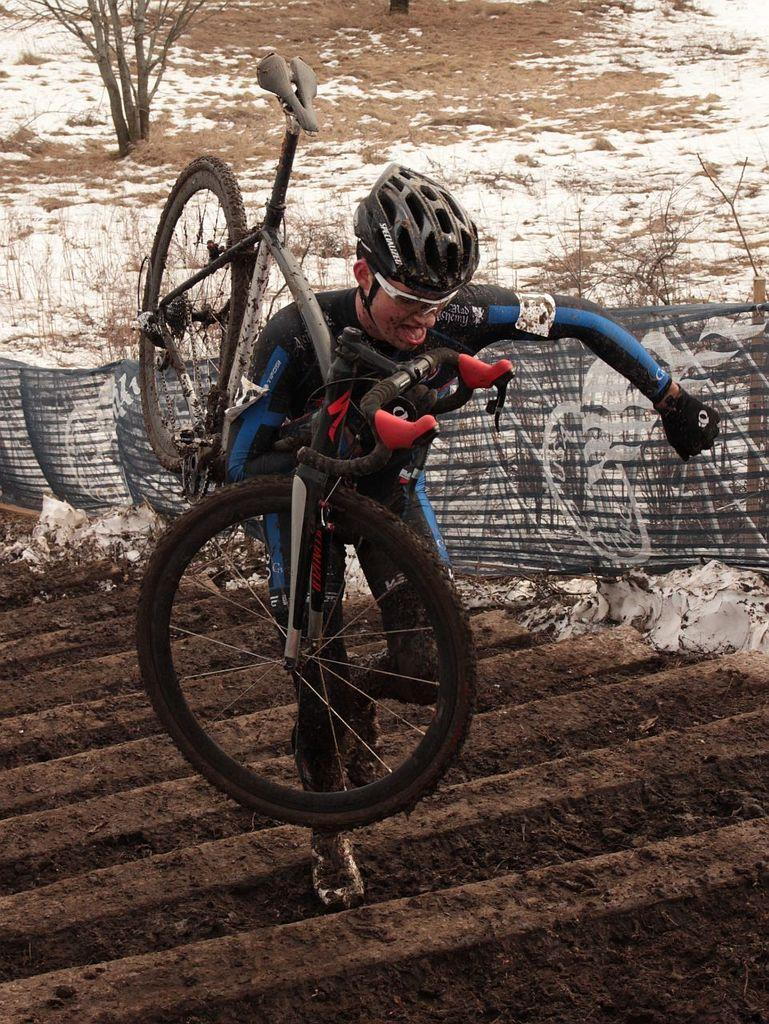What is the main subject of the image? There is a man in the image. What is the man holding in the image? The man is holding a bicycle. What action is the man performing in the image? The man is climbing stairs. What can be seen in the background of the image? There is snow and trees in the background of the image. What type of umbrella is the man using to protect himself from the snow in the image? There is no umbrella present in the image; the man is not using any protection from the snow. What is the end result of the man climbing the stairs in the image? The image only shows the man in the process of climbing the stairs, so it does not depict the end result of his action. 